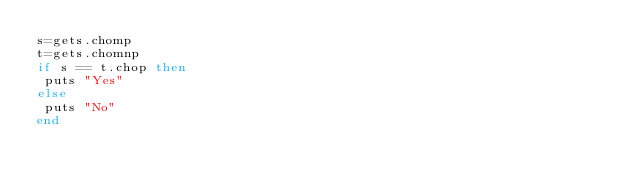<code> <loc_0><loc_0><loc_500><loc_500><_Ruby_>s=gets.chomp
t=gets.chomnp
if s == t.chop then
 puts "Yes"
else
 puts "No"
end</code> 